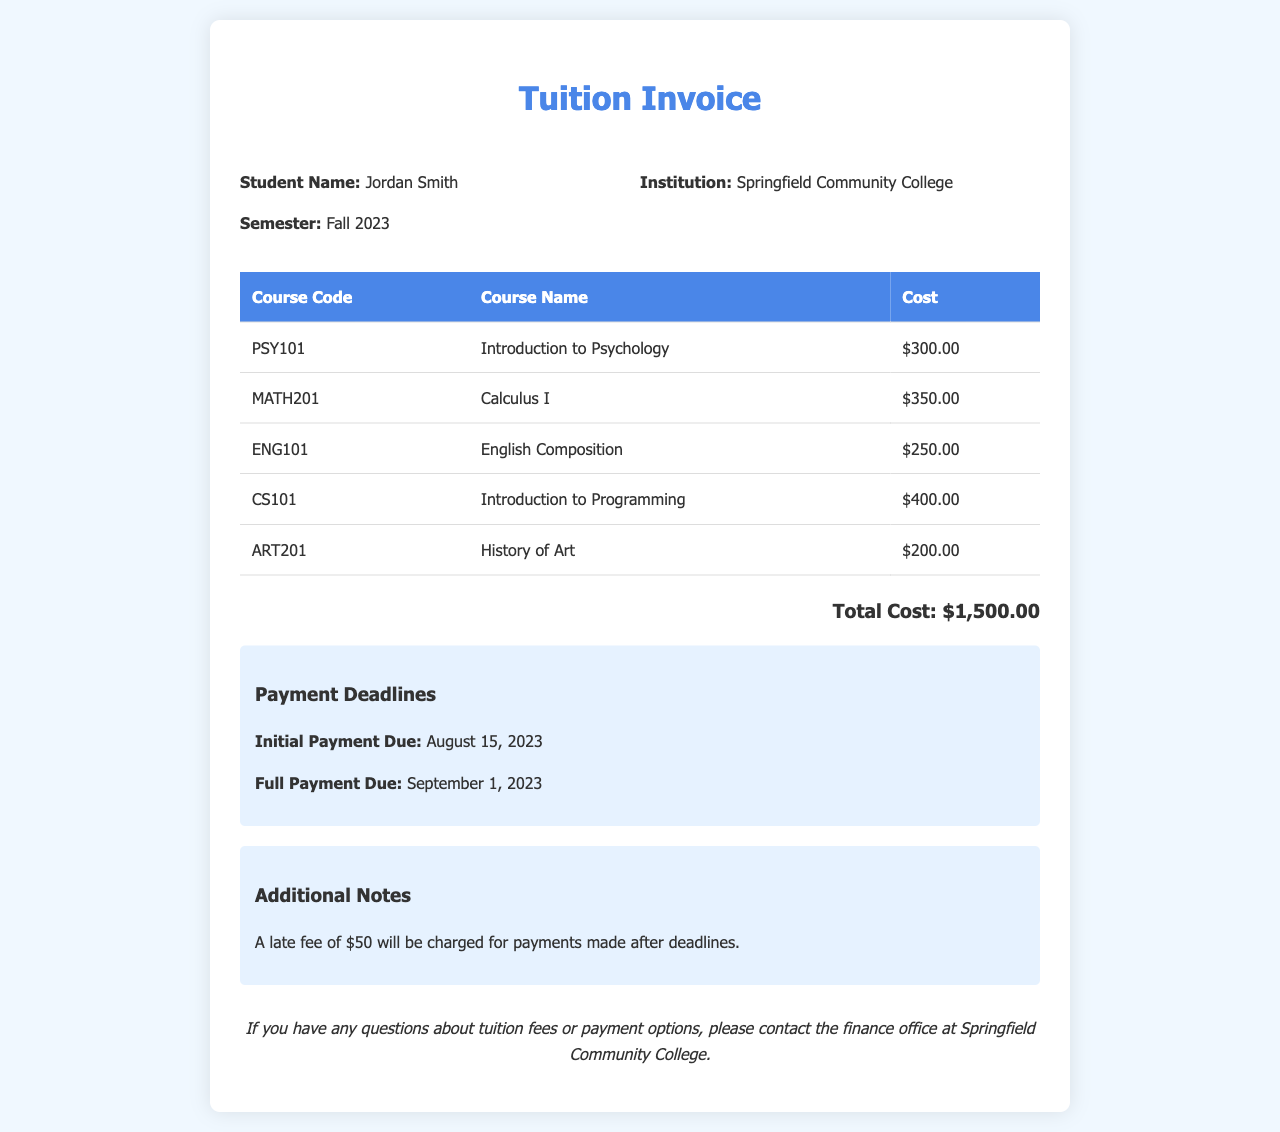What is the total cost of tuition? The total cost is calculated from the sum of all course costs listed in the invoice, which amounts to $300.00 + $350.00 + $250.00 + $400.00 + $200.00.
Answer: $1,500.00 Who is the student? The document specifies the name of the student at the top under student information.
Answer: Jordan Smith When is the full payment due? The payment deadlines section of the invoice lists the date when full payment is required.
Answer: September 1, 2023 How many courses are listed in the invoice? By counting the courses in the table, you will find the number of courses described.
Answer: 5 What is the late fee for payments made after the deadlines? The invoices include notes regarding fees applicable after the payment deadlines.
Answer: $50 What is the cost of Introduction to Psychology? The course cost is detailed in the itemized course table.
Answer: $300.00 Which college issued this invoice? The college information is provided in the header of the invoice.
Answer: Springfield Community College What courses are available for this semester? The courses are listed in the invoice under the course details section, showing all courses available.
Answer: Introduction to Psychology, Calculus I, English Composition, Introduction to Programming, History of Art 